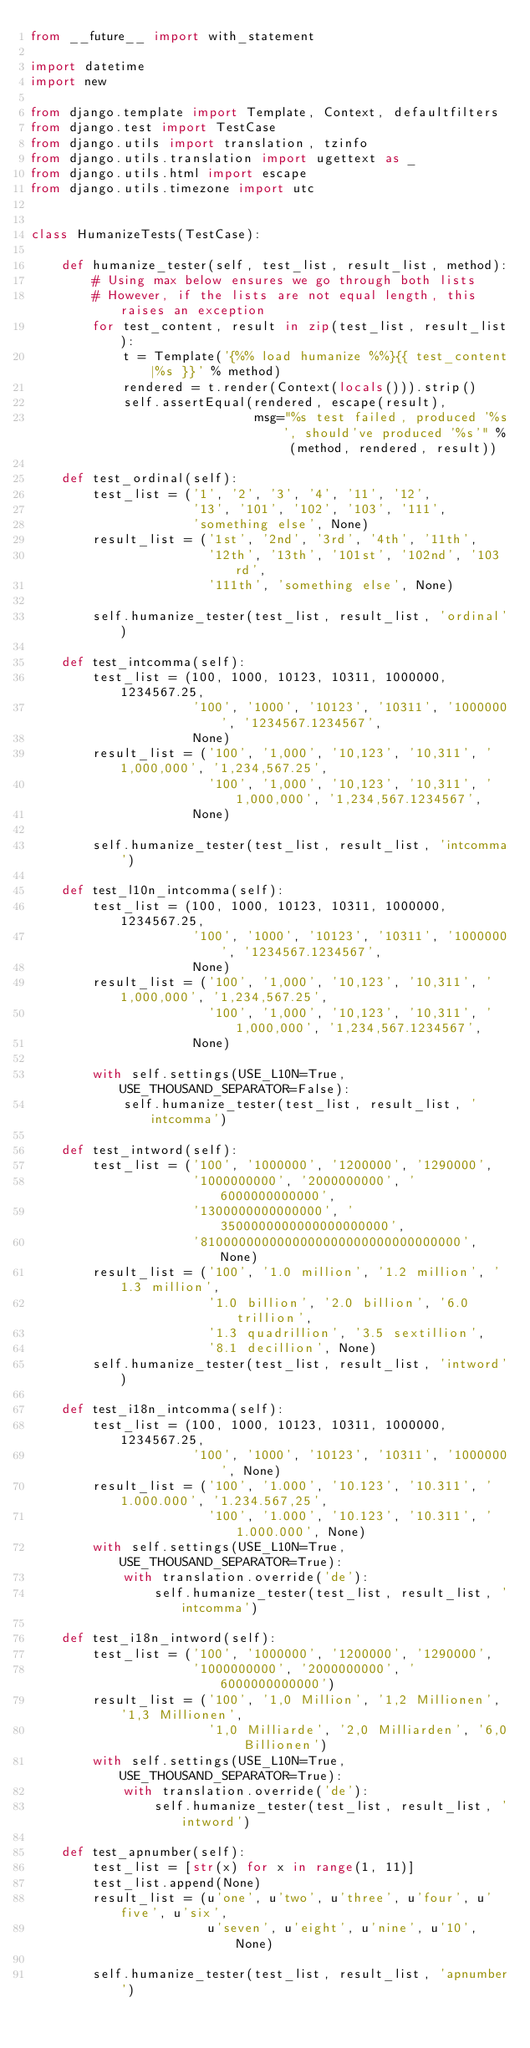<code> <loc_0><loc_0><loc_500><loc_500><_Python_>from __future__ import with_statement

import datetime
import new

from django.template import Template, Context, defaultfilters
from django.test import TestCase
from django.utils import translation, tzinfo
from django.utils.translation import ugettext as _
from django.utils.html import escape
from django.utils.timezone import utc


class HumanizeTests(TestCase):

    def humanize_tester(self, test_list, result_list, method):
        # Using max below ensures we go through both lists
        # However, if the lists are not equal length, this raises an exception
        for test_content, result in zip(test_list, result_list):
            t = Template('{%% load humanize %%}{{ test_content|%s }}' % method)
            rendered = t.render(Context(locals())).strip()
            self.assertEqual(rendered, escape(result),
                             msg="%s test failed, produced '%s', should've produced '%s'" % (method, rendered, result))

    def test_ordinal(self):
        test_list = ('1', '2', '3', '4', '11', '12',
                     '13', '101', '102', '103', '111',
                     'something else', None)
        result_list = ('1st', '2nd', '3rd', '4th', '11th',
                       '12th', '13th', '101st', '102nd', '103rd',
                       '111th', 'something else', None)

        self.humanize_tester(test_list, result_list, 'ordinal')

    def test_intcomma(self):
        test_list = (100, 1000, 10123, 10311, 1000000, 1234567.25,
                     '100', '1000', '10123', '10311', '1000000', '1234567.1234567',
                     None)
        result_list = ('100', '1,000', '10,123', '10,311', '1,000,000', '1,234,567.25',
                       '100', '1,000', '10,123', '10,311', '1,000,000', '1,234,567.1234567',
                     None)

        self.humanize_tester(test_list, result_list, 'intcomma')

    def test_l10n_intcomma(self):
        test_list = (100, 1000, 10123, 10311, 1000000, 1234567.25,
                     '100', '1000', '10123', '10311', '1000000', '1234567.1234567',
                     None)
        result_list = ('100', '1,000', '10,123', '10,311', '1,000,000', '1,234,567.25',
                       '100', '1,000', '10,123', '10,311', '1,000,000', '1,234,567.1234567',
                     None)

        with self.settings(USE_L10N=True, USE_THOUSAND_SEPARATOR=False):
            self.humanize_tester(test_list, result_list, 'intcomma')

    def test_intword(self):
        test_list = ('100', '1000000', '1200000', '1290000',
                     '1000000000', '2000000000', '6000000000000',
                     '1300000000000000', '3500000000000000000000',
                     '8100000000000000000000000000000000', None)
        result_list = ('100', '1.0 million', '1.2 million', '1.3 million',
                       '1.0 billion', '2.0 billion', '6.0 trillion',
                       '1.3 quadrillion', '3.5 sextillion',
                       '8.1 decillion', None)
        self.humanize_tester(test_list, result_list, 'intword')

    def test_i18n_intcomma(self):
        test_list = (100, 1000, 10123, 10311, 1000000, 1234567.25,
                     '100', '1000', '10123', '10311', '1000000', None)
        result_list = ('100', '1.000', '10.123', '10.311', '1.000.000', '1.234.567,25',
                       '100', '1.000', '10.123', '10.311', '1.000.000', None)
        with self.settings(USE_L10N=True, USE_THOUSAND_SEPARATOR=True):
            with translation.override('de'):
                self.humanize_tester(test_list, result_list, 'intcomma')

    def test_i18n_intword(self):
        test_list = ('100', '1000000', '1200000', '1290000',
                     '1000000000', '2000000000', '6000000000000')
        result_list = ('100', '1,0 Million', '1,2 Millionen', '1,3 Millionen',
                       '1,0 Milliarde', '2,0 Milliarden', '6,0 Billionen')
        with self.settings(USE_L10N=True, USE_THOUSAND_SEPARATOR=True):
            with translation.override('de'):
                self.humanize_tester(test_list, result_list, 'intword')

    def test_apnumber(self):
        test_list = [str(x) for x in range(1, 11)]
        test_list.append(None)
        result_list = (u'one', u'two', u'three', u'four', u'five', u'six',
                       u'seven', u'eight', u'nine', u'10', None)

        self.humanize_tester(test_list, result_list, 'apnumber')
</code> 